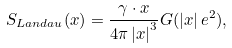Convert formula to latex. <formula><loc_0><loc_0><loc_500><loc_500>S _ { L a n d a u } ( x ) = \frac { \gamma \cdot x } { 4 \pi \left | x \right | ^ { 3 } } G ( \left | x \right | e ^ { 2 } ) ,</formula> 